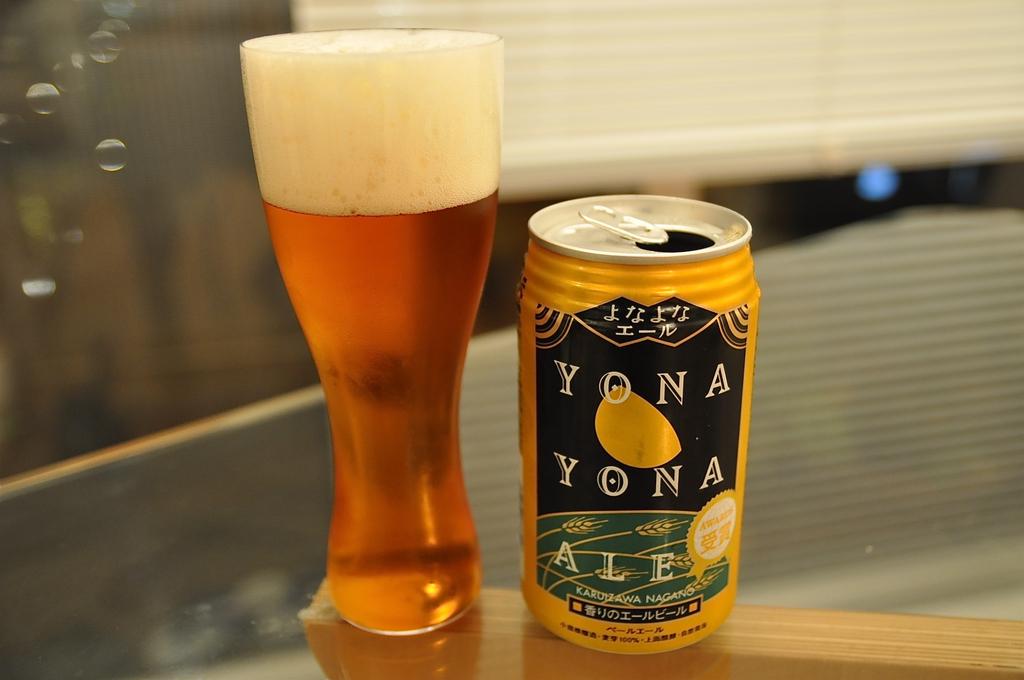What is the kind of ale?
Your response must be concise. Yona yona. What is the name of the ale in the can?
Keep it short and to the point. Yona yona. 